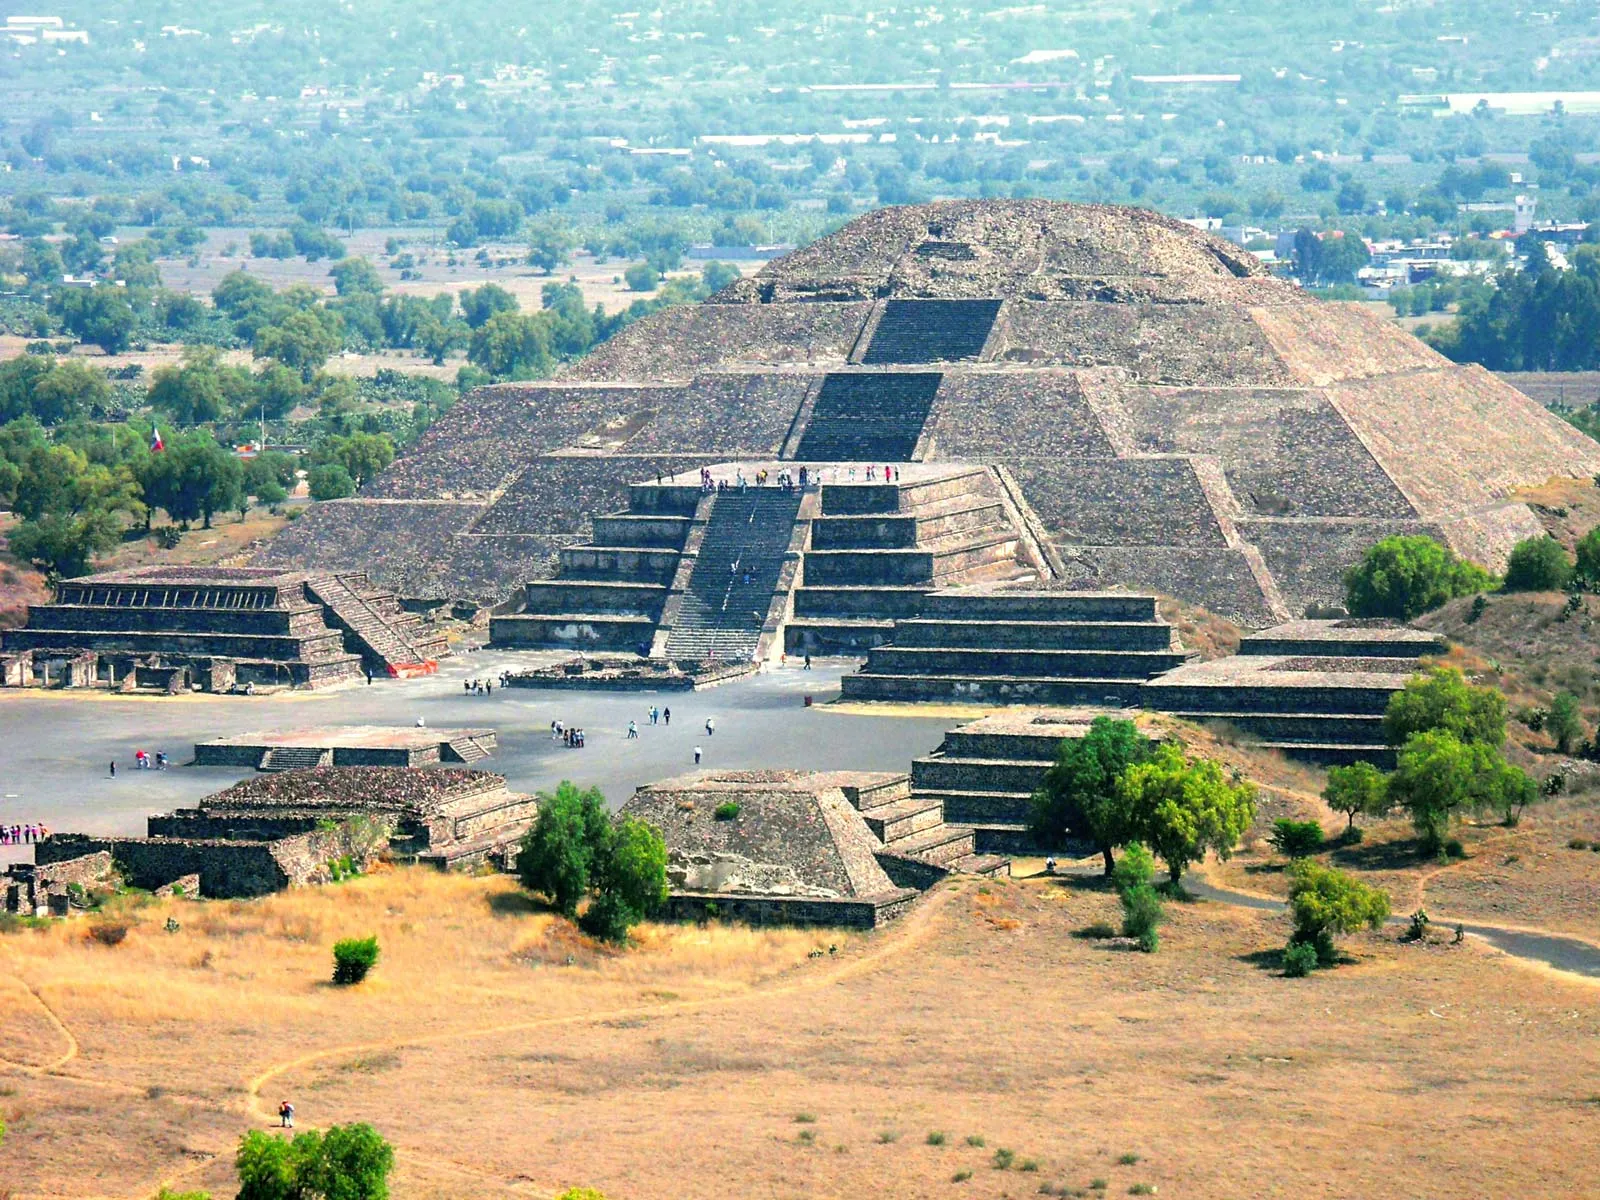What are some of the striking natural features around the pyramid? The surroundings of the Pyramid of the Sun are characterized by several striking natural features. The lush expanse of trees enlivens the landscape with their vibrant green, providing a beautiful contrast to the earthy tones of the pyramid. The area is dotted with various flora, contributing to a rich biodiversity that enhances the aesthetic appeal of the site. In the distance, the hazy blue of the horizon merges with the sky, adding depth to the scene. The terrain around the pyramid includes gentle slopes and flat open spaces that once accommodated lively gatherings and markets in ancient times. The interplay of natural elements around the pyramid not only highlights the magnificence of this historical structure but also creates a serene and picturesque environment that captivates visitors. 